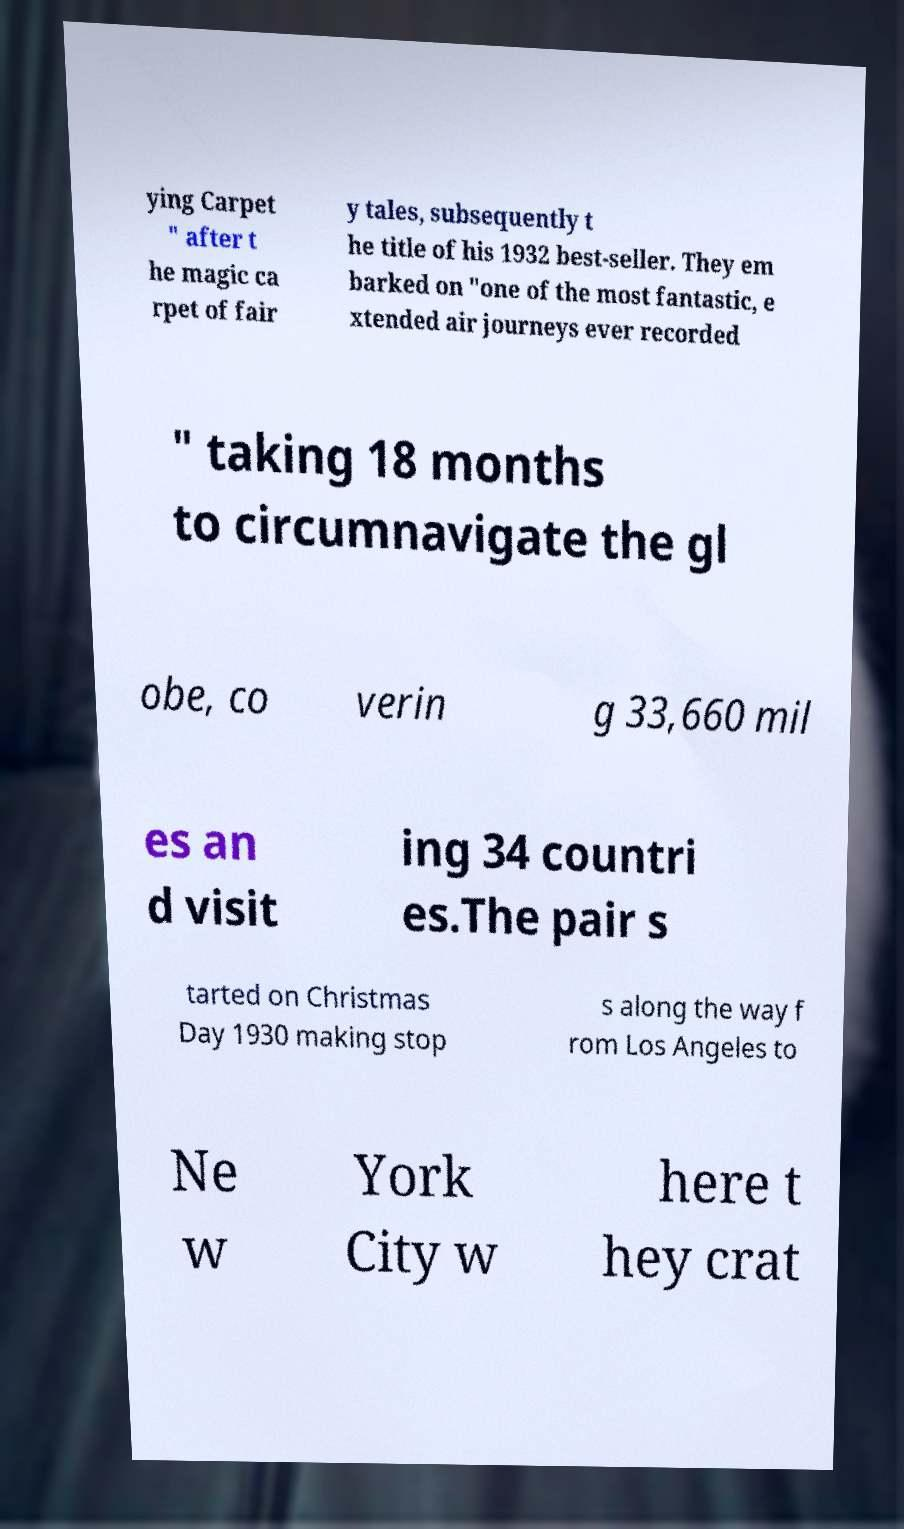There's text embedded in this image that I need extracted. Can you transcribe it verbatim? ying Carpet " after t he magic ca rpet of fair y tales, subsequently t he title of his 1932 best-seller. They em barked on "one of the most fantastic, e xtended air journeys ever recorded " taking 18 months to circumnavigate the gl obe, co verin g 33,660 mil es an d visit ing 34 countri es.The pair s tarted on Christmas Day 1930 making stop s along the way f rom Los Angeles to Ne w York City w here t hey crat 